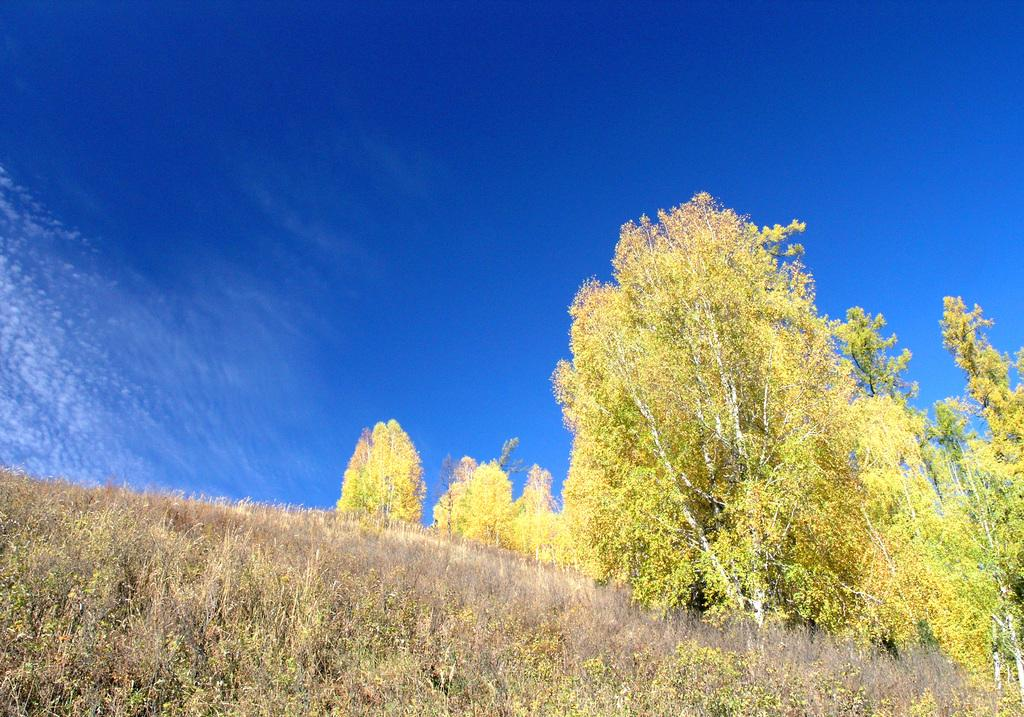What type of vegetation can be seen in the image? There are trees in the image. What part of the natural environment is visible in the image? The sky is visible in the background of the image. What type of ornament is hanging from the tree in the image? There is no ornament hanging from the tree in the image; only trees and the sky are visible. Can you tell me how many jars are on the tree in the image? There are no jars present in the image. 